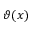<formula> <loc_0><loc_0><loc_500><loc_500>\vartheta ( x )</formula> 